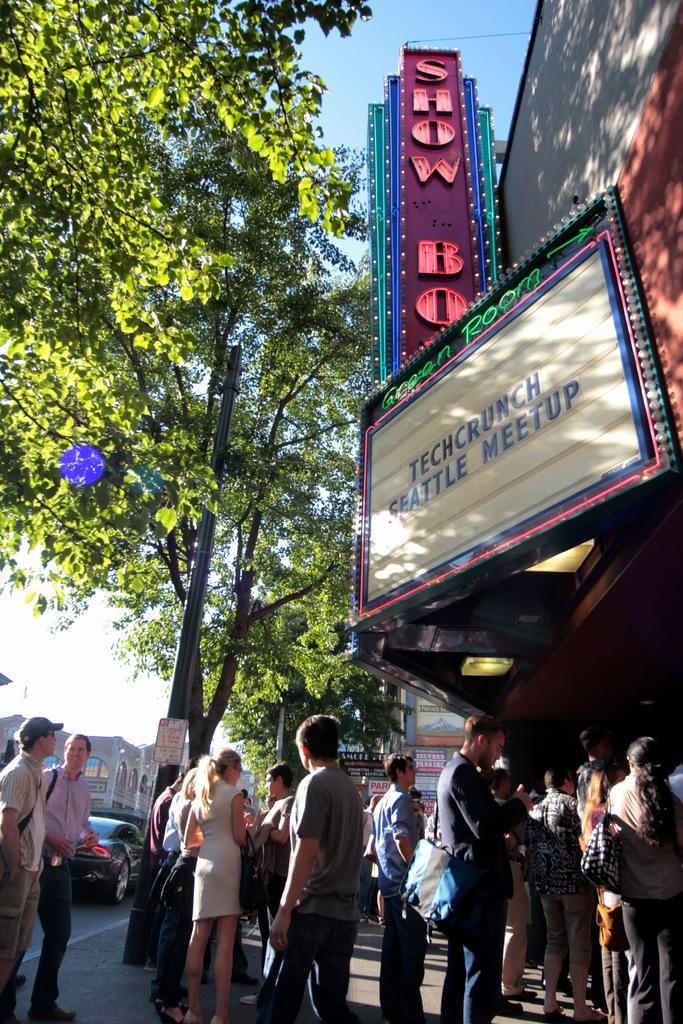Can you describe this image briefly? In this image I can see the road, few vehicles on the road, number of persons are standing on the ground, a budding, few boards to the building and few trees. In the background I can see few buildings and the sky. 